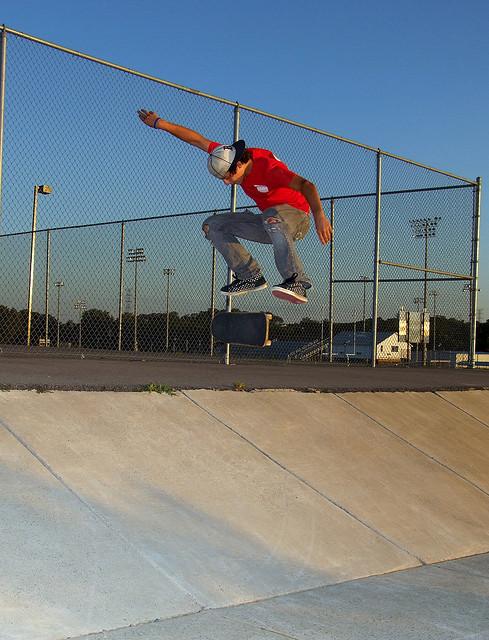Is the guy trying to jump over the fence?
Be succinct. No. Where is the skateboard?
Write a very short answer. Under boy. What color shirt is the person wearing?
Keep it brief. Red. 